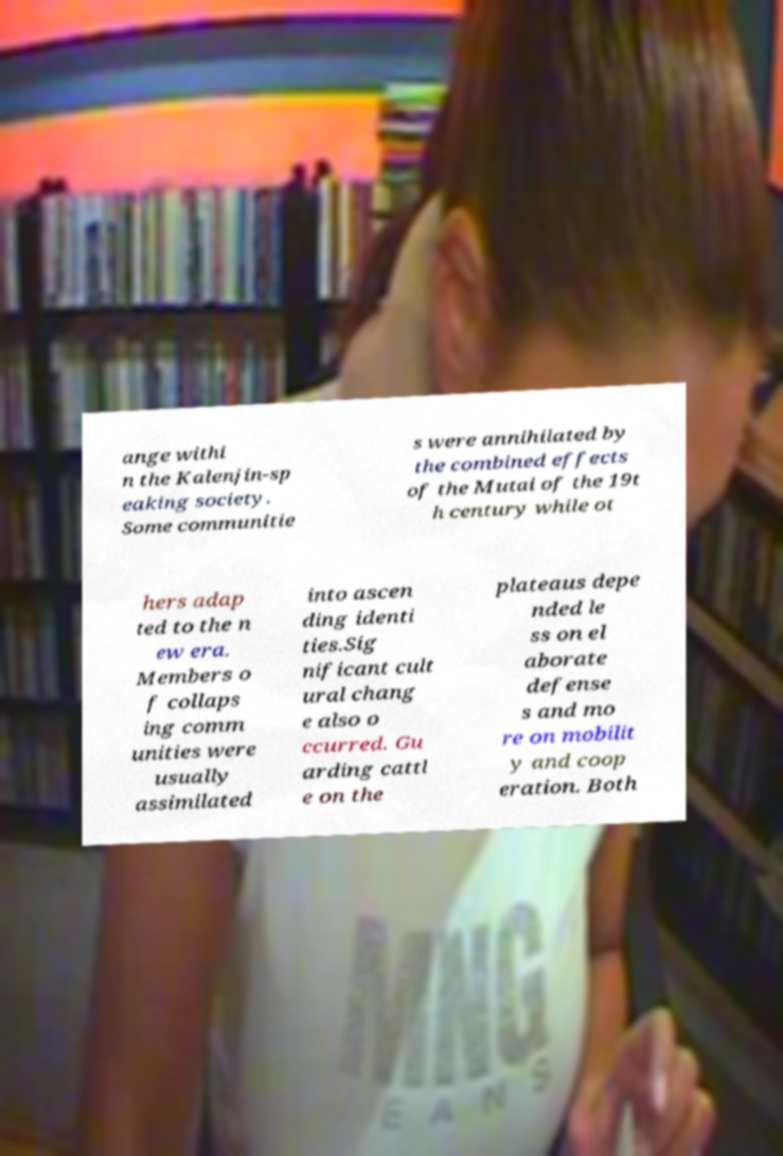I need the written content from this picture converted into text. Can you do that? ange withi n the Kalenjin-sp eaking society. Some communitie s were annihilated by the combined effects of the Mutai of the 19t h century while ot hers adap ted to the n ew era. Members o f collaps ing comm unities were usually assimilated into ascen ding identi ties.Sig nificant cult ural chang e also o ccurred. Gu arding cattl e on the plateaus depe nded le ss on el aborate defense s and mo re on mobilit y and coop eration. Both 